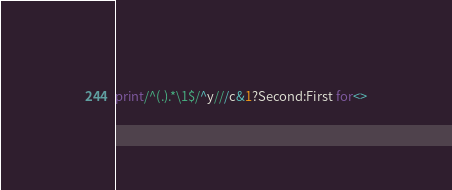<code> <loc_0><loc_0><loc_500><loc_500><_Perl_>print/^(.).*\1$/^y///c&1?Second:First for<></code> 